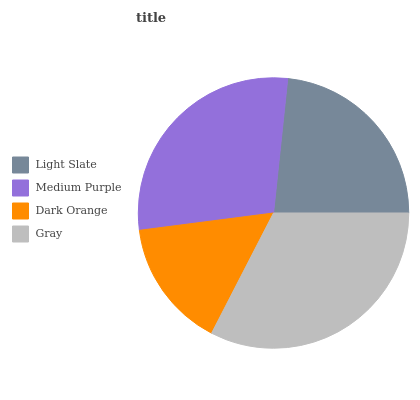Is Dark Orange the minimum?
Answer yes or no. Yes. Is Gray the maximum?
Answer yes or no. Yes. Is Medium Purple the minimum?
Answer yes or no. No. Is Medium Purple the maximum?
Answer yes or no. No. Is Medium Purple greater than Light Slate?
Answer yes or no. Yes. Is Light Slate less than Medium Purple?
Answer yes or no. Yes. Is Light Slate greater than Medium Purple?
Answer yes or no. No. Is Medium Purple less than Light Slate?
Answer yes or no. No. Is Medium Purple the high median?
Answer yes or no. Yes. Is Light Slate the low median?
Answer yes or no. Yes. Is Gray the high median?
Answer yes or no. No. Is Medium Purple the low median?
Answer yes or no. No. 